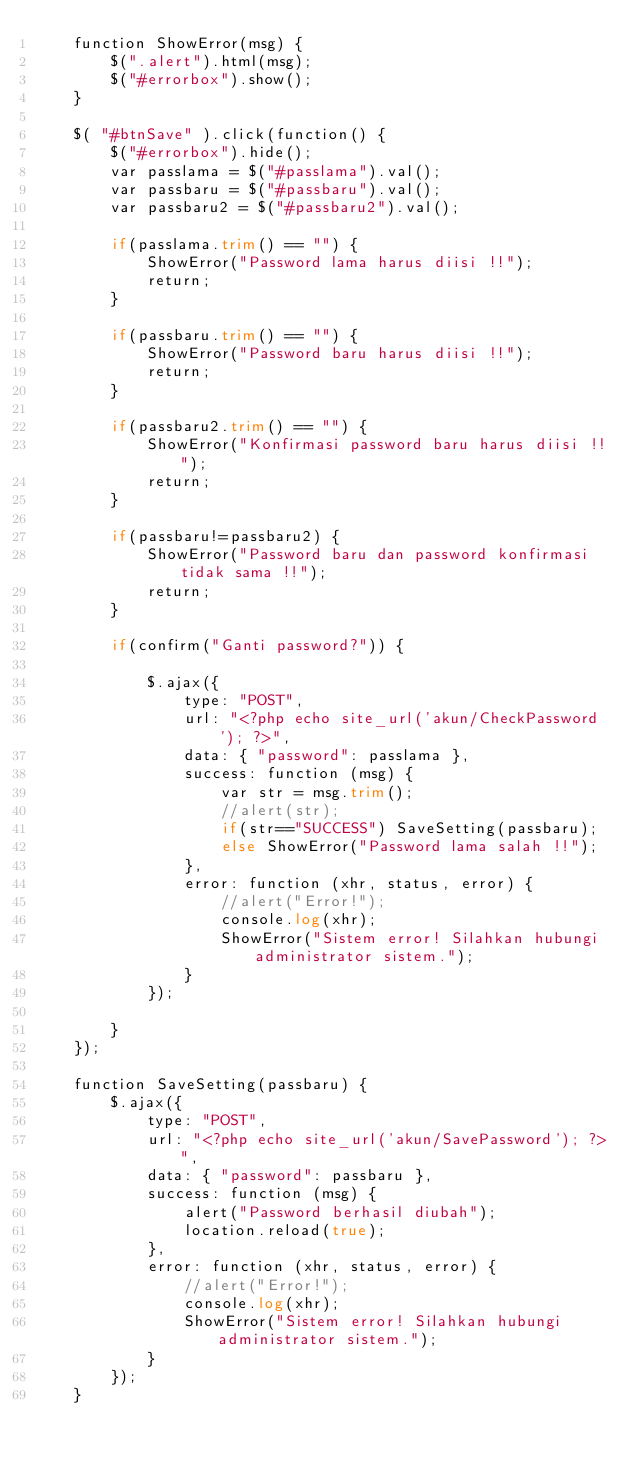<code> <loc_0><loc_0><loc_500><loc_500><_PHP_>	function ShowError(msg) {
    	$(".alert").html(msg);
    	$("#errorbox").show();
	}

	$( "#btnSave" ).click(function() {
    	$("#errorbox").hide();
    	var passlama = $("#passlama").val();
    	var passbaru = $("#passbaru").val();
    	var passbaru2 = $("#passbaru2").val();

    	if(passlama.trim() == "") {
			ShowError("Password lama harus diisi !!");
			return;
		}

    	if(passbaru.trim() == "") {
			ShowError("Password baru harus diisi !!");
			return;
		}

    	if(passbaru2.trim() == "") {
			ShowError("Konfirmasi password baru harus diisi !!");
			return;
		}

		if(passbaru!=passbaru2) {
			ShowError("Password baru dan password konfirmasi tidak sama !!");
			return;
		}

		if(confirm("Ganti password?")) {

	    	$.ajax({
		        type: "POST",
		        url: "<?php echo site_url('akun/CheckPassword'); ?>",
		        data: { "password": passlama },
		        success: function (msg) { 
		        	var str = msg.trim();
		        	//alert(str);
		        	if(str=="SUCCESS") SaveSetting(passbaru); 
		        	else ShowError("Password lama salah !!");
		        },
		        error: function (xhr, status, error) {
		            //alert("Error!");
		            console.log(xhr);
		            ShowError("Sistem error! Silahkan hubungi administrator sistem.");
		        }
		    });
			
		}
    });

    function SaveSetting(passbaru) {
    	$.ajax({
	        type: "POST",
	        url: "<?php echo site_url('akun/SavePassword'); ?>",
	        data: { "password": passbaru },
	        success: function (msg) {
	            alert("Password berhasil diubah");
	            location.reload(true);
	        },
	        error: function (xhr, status, error) {
	            //alert("Error!");
	            console.log(xhr);
	            ShowError("Sistem error! Silahkan hubungi administrator sistem.");
	        }
	    });
	}</code> 